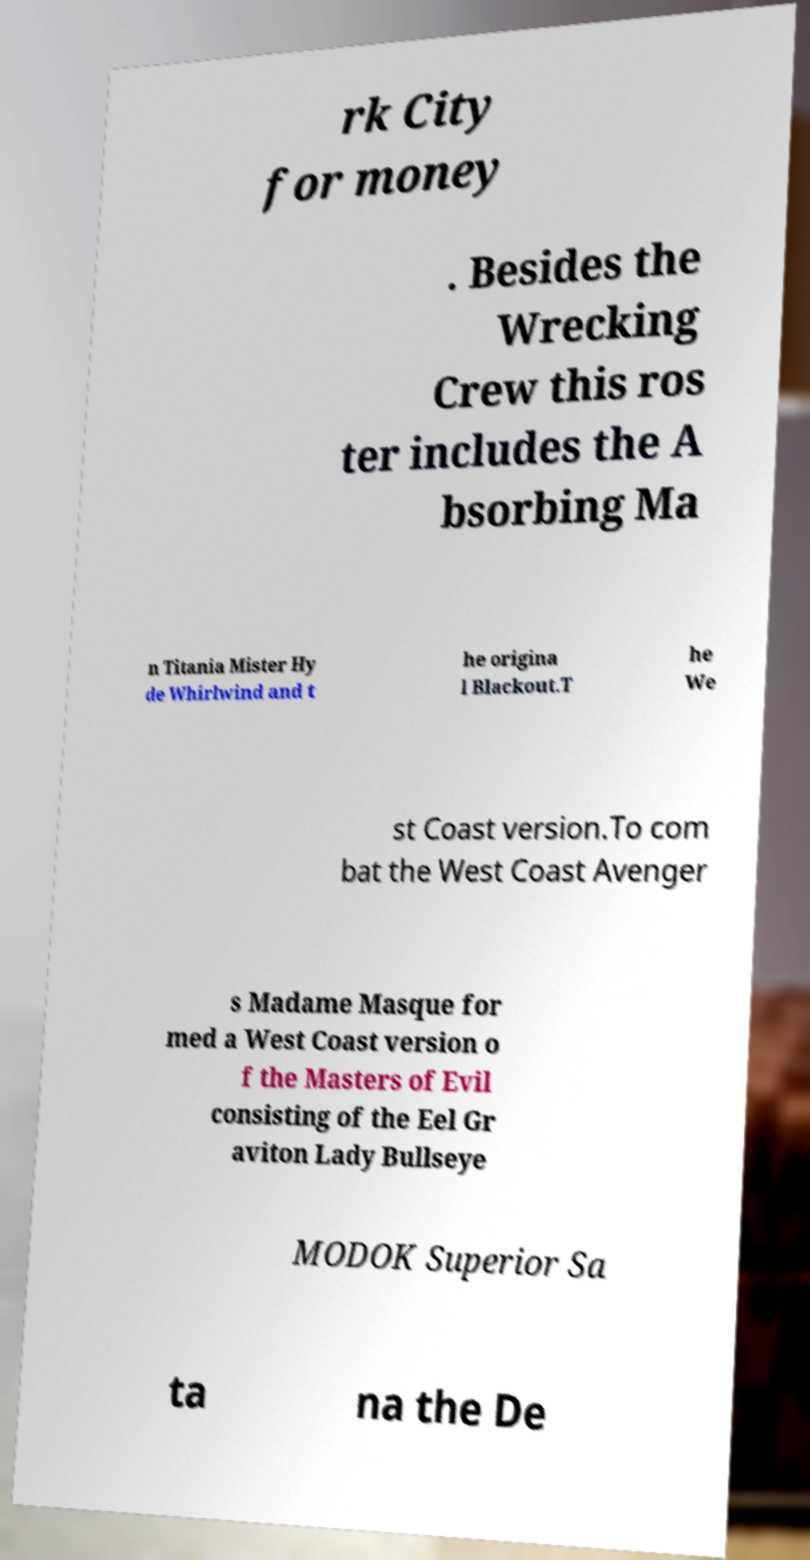Could you extract and type out the text from this image? rk City for money . Besides the Wrecking Crew this ros ter includes the A bsorbing Ma n Titania Mister Hy de Whirlwind and t he origina l Blackout.T he We st Coast version.To com bat the West Coast Avenger s Madame Masque for med a West Coast version o f the Masters of Evil consisting of the Eel Gr aviton Lady Bullseye MODOK Superior Sa ta na the De 